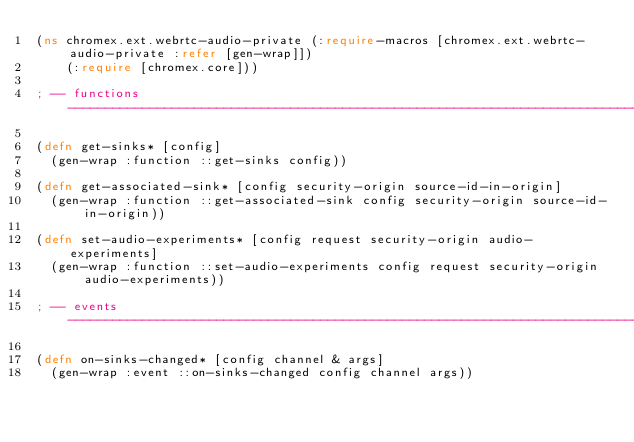<code> <loc_0><loc_0><loc_500><loc_500><_Clojure_>(ns chromex.ext.webrtc-audio-private (:require-macros [chromex.ext.webrtc-audio-private :refer [gen-wrap]])
    (:require [chromex.core]))

; -- functions --------------------------------------------------------------------------------------------------------------

(defn get-sinks* [config]
  (gen-wrap :function ::get-sinks config))

(defn get-associated-sink* [config security-origin source-id-in-origin]
  (gen-wrap :function ::get-associated-sink config security-origin source-id-in-origin))

(defn set-audio-experiments* [config request security-origin audio-experiments]
  (gen-wrap :function ::set-audio-experiments config request security-origin audio-experiments))

; -- events -----------------------------------------------------------------------------------------------------------------

(defn on-sinks-changed* [config channel & args]
  (gen-wrap :event ::on-sinks-changed config channel args))

</code> 